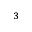Convert formula to latex. <formula><loc_0><loc_0><loc_500><loc_500>^ { 3 }</formula> 